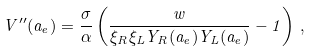<formula> <loc_0><loc_0><loc_500><loc_500>V ^ { \prime \prime } ( a _ { e } ) = \frac { \sigma } { \alpha } \left ( \frac { w } { \xi _ { R } \xi _ { L } Y _ { R } ( a _ { e } ) Y _ { L } ( a _ { e } ) } - 1 \right ) \, ,</formula> 